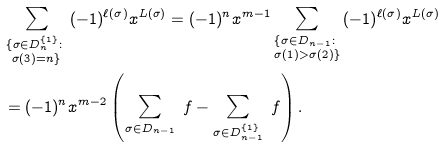Convert formula to latex. <formula><loc_0><loc_0><loc_500><loc_500>& \sum _ { \substack { \{ \sigma \in D _ { n } ^ { \{ 1 \} } \colon \\ \sigma ( 3 ) = n \} } } { ( - 1 ) ^ { \ell ( \sigma ) } x ^ { L ( \sigma ) } } = ( - 1 ) ^ { n } x ^ { m - 1 } \sum _ { \substack { \{ \sigma \in D _ { n - 1 } \colon \\ \sigma ( 1 ) > \sigma ( 2 ) \} } } { ( - 1 ) ^ { \ell ( \sigma ) } x ^ { L ( \sigma ) } } \\ & = ( - 1 ) ^ { n } x ^ { m - 2 } \left ( \sum _ { \sigma \in D _ { n - 1 } } \ f - \sum _ { \sigma \in D _ { n - 1 } ^ { \{ 1 \} } } \ f \right ) .</formula> 